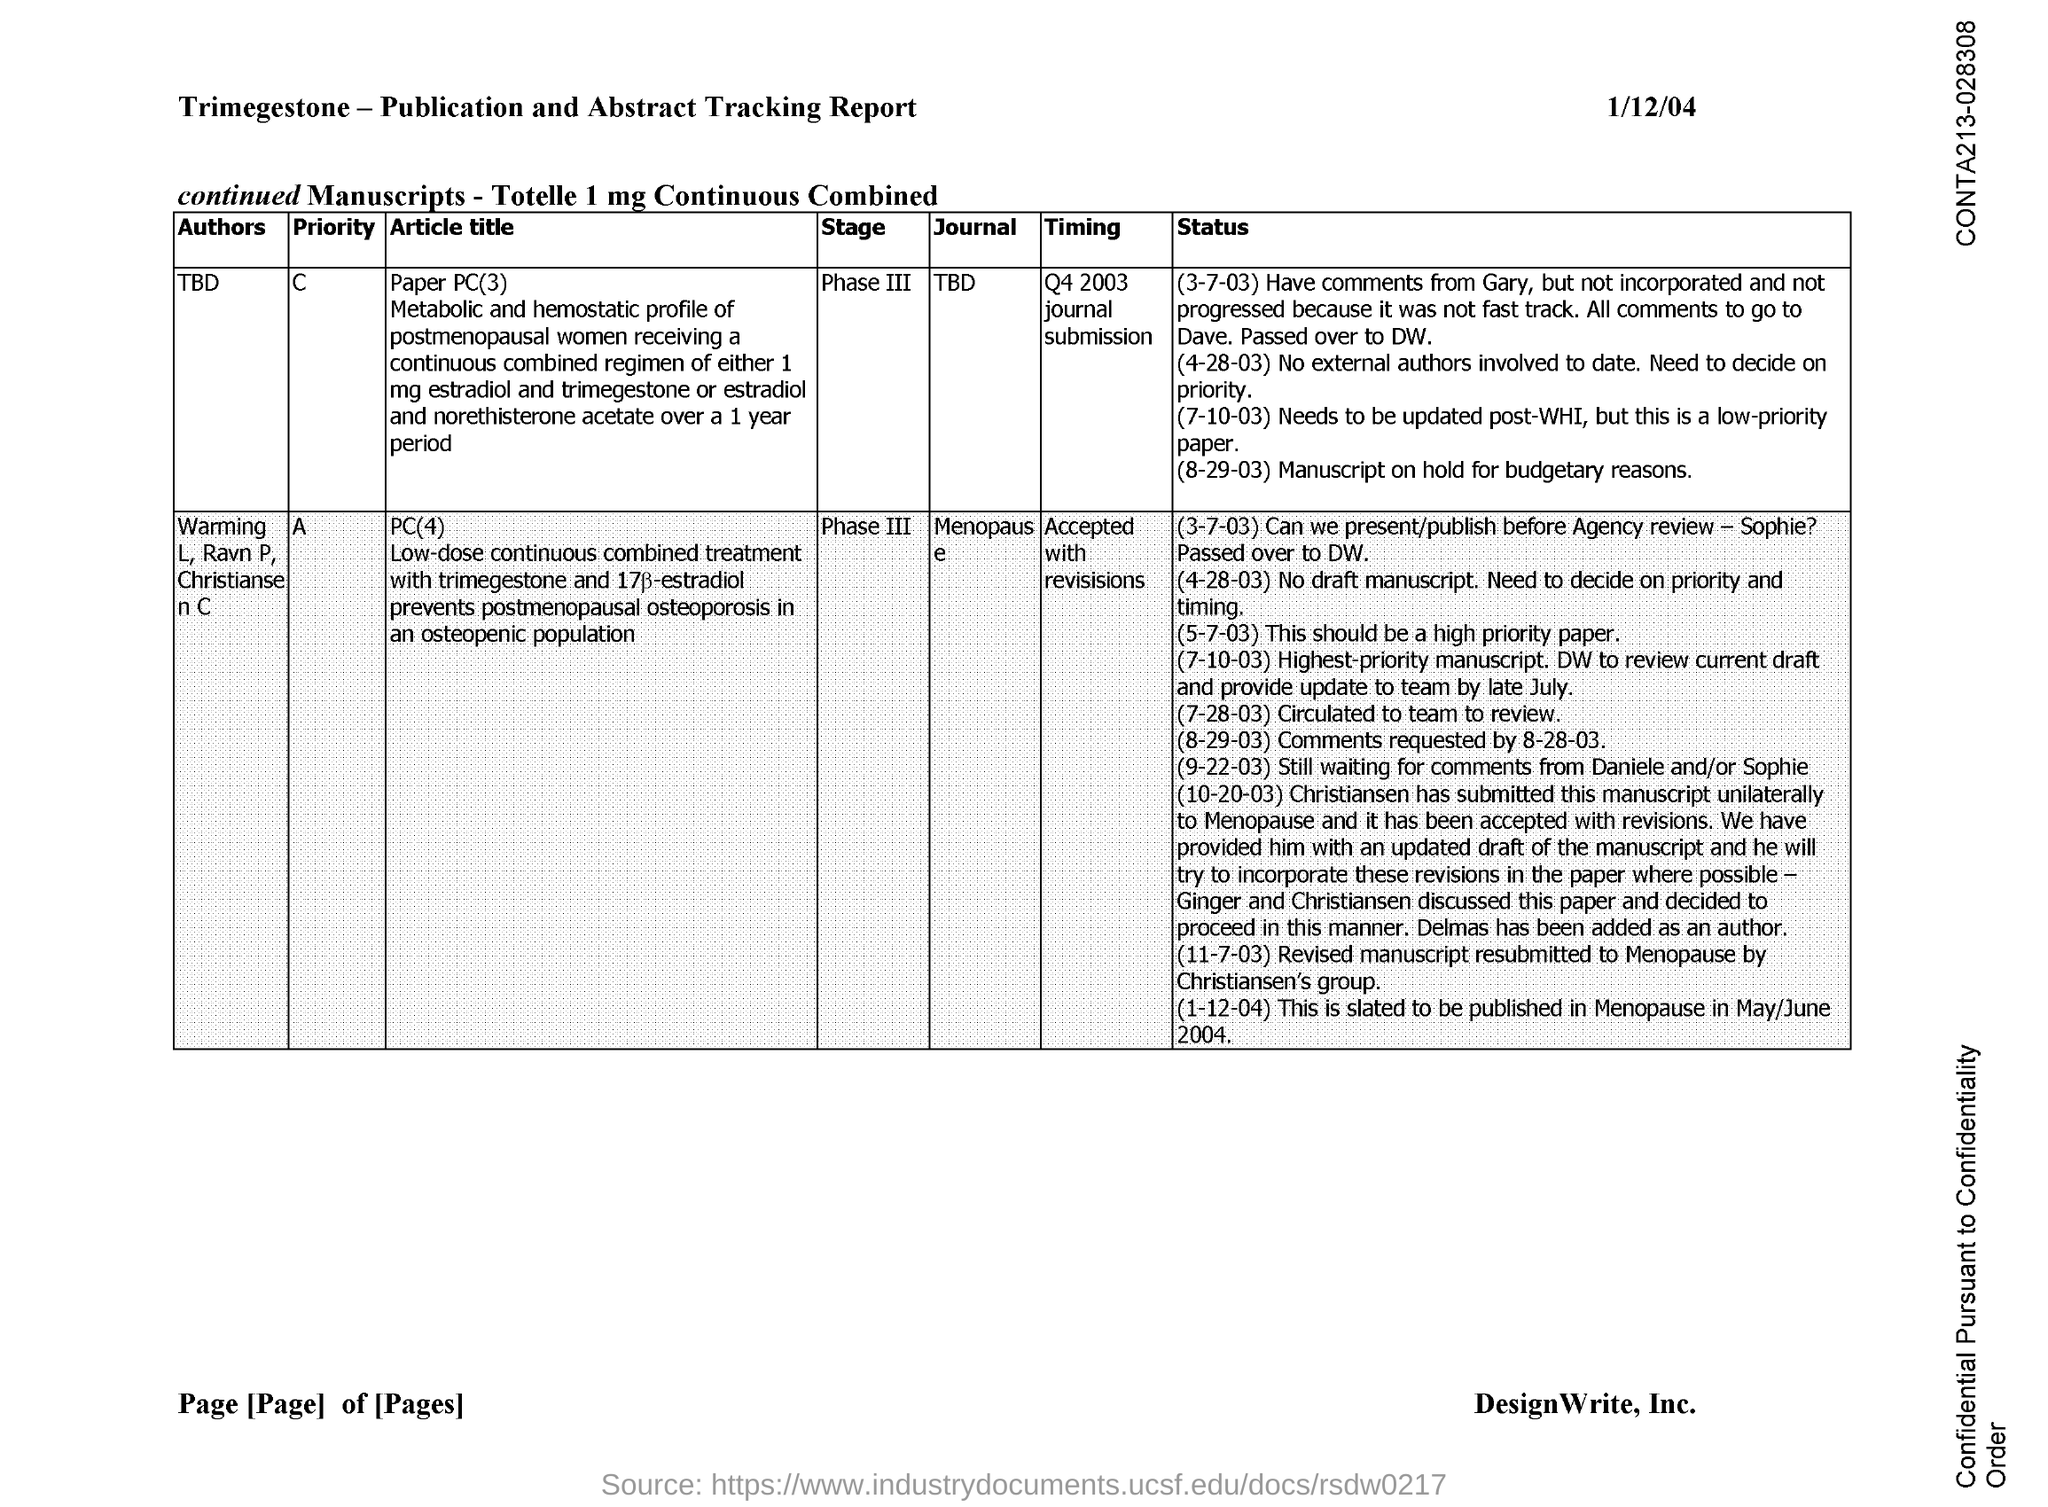Give some essential details in this illustration. The date on the document is January 12, 2004. 